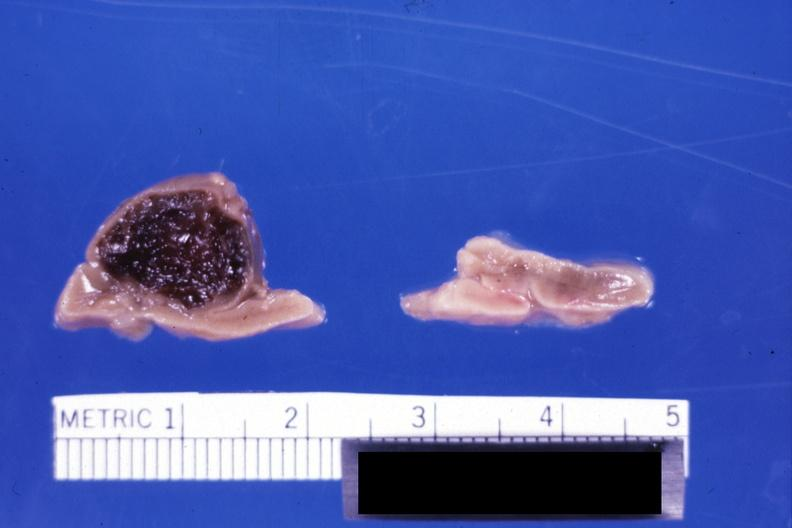what does this image show?
Answer the question using a single word or phrase. Fixed tissue but not bad color stillborn infant maternal sepsis e coli hemorrhaged into peritoneum 